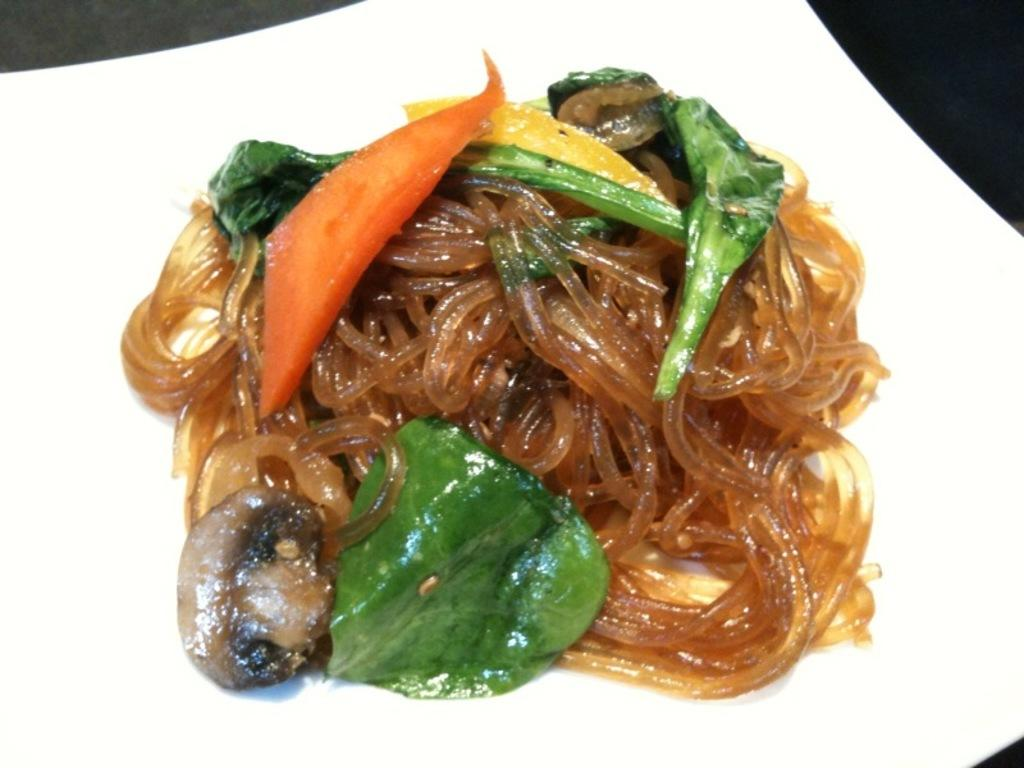What type of food can be seen in the image? The food in the image includes noodles. How are the noodles arranged or presented? The noodles are placed on a platter. Where is the platter with noodles located in the image? The platter is in the foreground of the image. What color is the feather that is being used to season the noodles in the image? There is no feather present in the image, and no seasoning is visible on the noodles. 